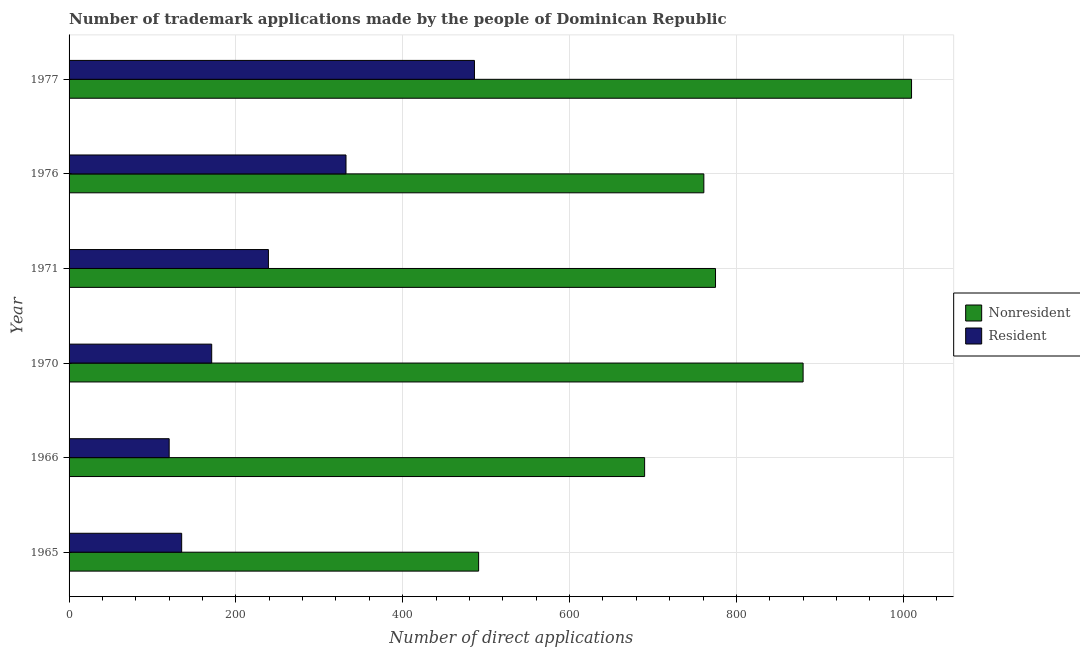How many groups of bars are there?
Provide a short and direct response. 6. Are the number of bars per tick equal to the number of legend labels?
Provide a succinct answer. Yes. Are the number of bars on each tick of the Y-axis equal?
Provide a short and direct response. Yes. What is the label of the 4th group of bars from the top?
Give a very brief answer. 1970. In how many cases, is the number of bars for a given year not equal to the number of legend labels?
Provide a short and direct response. 0. What is the number of trademark applications made by non residents in 1966?
Ensure brevity in your answer.  690. Across all years, what is the maximum number of trademark applications made by residents?
Make the answer very short. 486. Across all years, what is the minimum number of trademark applications made by non residents?
Your answer should be very brief. 491. In which year was the number of trademark applications made by residents minimum?
Provide a succinct answer. 1966. What is the total number of trademark applications made by residents in the graph?
Your answer should be very brief. 1483. What is the difference between the number of trademark applications made by non residents in 1965 and that in 1970?
Ensure brevity in your answer.  -389. What is the difference between the number of trademark applications made by non residents in 1971 and the number of trademark applications made by residents in 1965?
Your answer should be compact. 640. What is the average number of trademark applications made by residents per year?
Ensure brevity in your answer.  247.17. In the year 1970, what is the difference between the number of trademark applications made by residents and number of trademark applications made by non residents?
Your response must be concise. -709. In how many years, is the number of trademark applications made by non residents greater than 840 ?
Your response must be concise. 2. What is the ratio of the number of trademark applications made by non residents in 1970 to that in 1977?
Make the answer very short. 0.87. Is the difference between the number of trademark applications made by residents in 1966 and 1977 greater than the difference between the number of trademark applications made by non residents in 1966 and 1977?
Offer a very short reply. No. What is the difference between the highest and the second highest number of trademark applications made by non residents?
Provide a short and direct response. 130. What is the difference between the highest and the lowest number of trademark applications made by residents?
Offer a very short reply. 366. What does the 2nd bar from the top in 1977 represents?
Keep it short and to the point. Nonresident. What does the 2nd bar from the bottom in 1977 represents?
Offer a very short reply. Resident. Are all the bars in the graph horizontal?
Your response must be concise. Yes. Does the graph contain any zero values?
Make the answer very short. No. How many legend labels are there?
Provide a short and direct response. 2. How are the legend labels stacked?
Keep it short and to the point. Vertical. What is the title of the graph?
Ensure brevity in your answer.  Number of trademark applications made by the people of Dominican Republic. What is the label or title of the X-axis?
Ensure brevity in your answer.  Number of direct applications. What is the label or title of the Y-axis?
Give a very brief answer. Year. What is the Number of direct applications of Nonresident in 1965?
Provide a succinct answer. 491. What is the Number of direct applications in Resident in 1965?
Provide a succinct answer. 135. What is the Number of direct applications of Nonresident in 1966?
Your response must be concise. 690. What is the Number of direct applications in Resident in 1966?
Provide a succinct answer. 120. What is the Number of direct applications in Nonresident in 1970?
Offer a terse response. 880. What is the Number of direct applications in Resident in 1970?
Ensure brevity in your answer.  171. What is the Number of direct applications of Nonresident in 1971?
Offer a terse response. 775. What is the Number of direct applications in Resident in 1971?
Offer a very short reply. 239. What is the Number of direct applications in Nonresident in 1976?
Your answer should be compact. 761. What is the Number of direct applications of Resident in 1976?
Provide a succinct answer. 332. What is the Number of direct applications of Nonresident in 1977?
Your answer should be very brief. 1010. What is the Number of direct applications of Resident in 1977?
Provide a succinct answer. 486. Across all years, what is the maximum Number of direct applications in Nonresident?
Your answer should be compact. 1010. Across all years, what is the maximum Number of direct applications of Resident?
Your answer should be compact. 486. Across all years, what is the minimum Number of direct applications in Nonresident?
Give a very brief answer. 491. Across all years, what is the minimum Number of direct applications of Resident?
Offer a very short reply. 120. What is the total Number of direct applications in Nonresident in the graph?
Give a very brief answer. 4607. What is the total Number of direct applications of Resident in the graph?
Give a very brief answer. 1483. What is the difference between the Number of direct applications in Nonresident in 1965 and that in 1966?
Provide a short and direct response. -199. What is the difference between the Number of direct applications in Nonresident in 1965 and that in 1970?
Make the answer very short. -389. What is the difference between the Number of direct applications in Resident in 1965 and that in 1970?
Offer a very short reply. -36. What is the difference between the Number of direct applications in Nonresident in 1965 and that in 1971?
Provide a short and direct response. -284. What is the difference between the Number of direct applications of Resident in 1965 and that in 1971?
Your answer should be compact. -104. What is the difference between the Number of direct applications in Nonresident in 1965 and that in 1976?
Offer a terse response. -270. What is the difference between the Number of direct applications in Resident in 1965 and that in 1976?
Provide a short and direct response. -197. What is the difference between the Number of direct applications of Nonresident in 1965 and that in 1977?
Your response must be concise. -519. What is the difference between the Number of direct applications in Resident in 1965 and that in 1977?
Provide a succinct answer. -351. What is the difference between the Number of direct applications in Nonresident in 1966 and that in 1970?
Your answer should be compact. -190. What is the difference between the Number of direct applications of Resident in 1966 and that in 1970?
Give a very brief answer. -51. What is the difference between the Number of direct applications in Nonresident in 1966 and that in 1971?
Your response must be concise. -85. What is the difference between the Number of direct applications of Resident in 1966 and that in 1971?
Ensure brevity in your answer.  -119. What is the difference between the Number of direct applications in Nonresident in 1966 and that in 1976?
Keep it short and to the point. -71. What is the difference between the Number of direct applications of Resident in 1966 and that in 1976?
Give a very brief answer. -212. What is the difference between the Number of direct applications in Nonresident in 1966 and that in 1977?
Provide a succinct answer. -320. What is the difference between the Number of direct applications of Resident in 1966 and that in 1977?
Offer a terse response. -366. What is the difference between the Number of direct applications of Nonresident in 1970 and that in 1971?
Ensure brevity in your answer.  105. What is the difference between the Number of direct applications in Resident in 1970 and that in 1971?
Your answer should be very brief. -68. What is the difference between the Number of direct applications of Nonresident in 1970 and that in 1976?
Make the answer very short. 119. What is the difference between the Number of direct applications in Resident in 1970 and that in 1976?
Provide a succinct answer. -161. What is the difference between the Number of direct applications in Nonresident in 1970 and that in 1977?
Your answer should be compact. -130. What is the difference between the Number of direct applications of Resident in 1970 and that in 1977?
Your answer should be compact. -315. What is the difference between the Number of direct applications of Nonresident in 1971 and that in 1976?
Your response must be concise. 14. What is the difference between the Number of direct applications in Resident in 1971 and that in 1976?
Keep it short and to the point. -93. What is the difference between the Number of direct applications in Nonresident in 1971 and that in 1977?
Provide a short and direct response. -235. What is the difference between the Number of direct applications in Resident in 1971 and that in 1977?
Make the answer very short. -247. What is the difference between the Number of direct applications of Nonresident in 1976 and that in 1977?
Offer a terse response. -249. What is the difference between the Number of direct applications of Resident in 1976 and that in 1977?
Offer a terse response. -154. What is the difference between the Number of direct applications of Nonresident in 1965 and the Number of direct applications of Resident in 1966?
Provide a succinct answer. 371. What is the difference between the Number of direct applications of Nonresident in 1965 and the Number of direct applications of Resident in 1970?
Offer a very short reply. 320. What is the difference between the Number of direct applications of Nonresident in 1965 and the Number of direct applications of Resident in 1971?
Provide a short and direct response. 252. What is the difference between the Number of direct applications in Nonresident in 1965 and the Number of direct applications in Resident in 1976?
Keep it short and to the point. 159. What is the difference between the Number of direct applications of Nonresident in 1966 and the Number of direct applications of Resident in 1970?
Your answer should be very brief. 519. What is the difference between the Number of direct applications in Nonresident in 1966 and the Number of direct applications in Resident in 1971?
Offer a terse response. 451. What is the difference between the Number of direct applications in Nonresident in 1966 and the Number of direct applications in Resident in 1976?
Provide a short and direct response. 358. What is the difference between the Number of direct applications of Nonresident in 1966 and the Number of direct applications of Resident in 1977?
Ensure brevity in your answer.  204. What is the difference between the Number of direct applications in Nonresident in 1970 and the Number of direct applications in Resident in 1971?
Ensure brevity in your answer.  641. What is the difference between the Number of direct applications of Nonresident in 1970 and the Number of direct applications of Resident in 1976?
Your response must be concise. 548. What is the difference between the Number of direct applications of Nonresident in 1970 and the Number of direct applications of Resident in 1977?
Your response must be concise. 394. What is the difference between the Number of direct applications of Nonresident in 1971 and the Number of direct applications of Resident in 1976?
Your answer should be compact. 443. What is the difference between the Number of direct applications in Nonresident in 1971 and the Number of direct applications in Resident in 1977?
Offer a very short reply. 289. What is the difference between the Number of direct applications of Nonresident in 1976 and the Number of direct applications of Resident in 1977?
Offer a very short reply. 275. What is the average Number of direct applications in Nonresident per year?
Make the answer very short. 767.83. What is the average Number of direct applications of Resident per year?
Your response must be concise. 247.17. In the year 1965, what is the difference between the Number of direct applications in Nonresident and Number of direct applications in Resident?
Offer a very short reply. 356. In the year 1966, what is the difference between the Number of direct applications in Nonresident and Number of direct applications in Resident?
Offer a very short reply. 570. In the year 1970, what is the difference between the Number of direct applications in Nonresident and Number of direct applications in Resident?
Your response must be concise. 709. In the year 1971, what is the difference between the Number of direct applications of Nonresident and Number of direct applications of Resident?
Provide a short and direct response. 536. In the year 1976, what is the difference between the Number of direct applications in Nonresident and Number of direct applications in Resident?
Your answer should be compact. 429. In the year 1977, what is the difference between the Number of direct applications of Nonresident and Number of direct applications of Resident?
Provide a short and direct response. 524. What is the ratio of the Number of direct applications in Nonresident in 1965 to that in 1966?
Keep it short and to the point. 0.71. What is the ratio of the Number of direct applications of Resident in 1965 to that in 1966?
Your answer should be compact. 1.12. What is the ratio of the Number of direct applications of Nonresident in 1965 to that in 1970?
Your answer should be compact. 0.56. What is the ratio of the Number of direct applications in Resident in 1965 to that in 1970?
Offer a very short reply. 0.79. What is the ratio of the Number of direct applications of Nonresident in 1965 to that in 1971?
Offer a very short reply. 0.63. What is the ratio of the Number of direct applications of Resident in 1965 to that in 1971?
Provide a short and direct response. 0.56. What is the ratio of the Number of direct applications in Nonresident in 1965 to that in 1976?
Keep it short and to the point. 0.65. What is the ratio of the Number of direct applications in Resident in 1965 to that in 1976?
Ensure brevity in your answer.  0.41. What is the ratio of the Number of direct applications of Nonresident in 1965 to that in 1977?
Give a very brief answer. 0.49. What is the ratio of the Number of direct applications of Resident in 1965 to that in 1977?
Your answer should be very brief. 0.28. What is the ratio of the Number of direct applications of Nonresident in 1966 to that in 1970?
Your response must be concise. 0.78. What is the ratio of the Number of direct applications of Resident in 1966 to that in 1970?
Offer a very short reply. 0.7. What is the ratio of the Number of direct applications in Nonresident in 1966 to that in 1971?
Your answer should be compact. 0.89. What is the ratio of the Number of direct applications in Resident in 1966 to that in 1971?
Give a very brief answer. 0.5. What is the ratio of the Number of direct applications of Nonresident in 1966 to that in 1976?
Offer a very short reply. 0.91. What is the ratio of the Number of direct applications in Resident in 1966 to that in 1976?
Ensure brevity in your answer.  0.36. What is the ratio of the Number of direct applications in Nonresident in 1966 to that in 1977?
Keep it short and to the point. 0.68. What is the ratio of the Number of direct applications in Resident in 1966 to that in 1977?
Offer a terse response. 0.25. What is the ratio of the Number of direct applications of Nonresident in 1970 to that in 1971?
Offer a very short reply. 1.14. What is the ratio of the Number of direct applications in Resident in 1970 to that in 1971?
Your answer should be compact. 0.72. What is the ratio of the Number of direct applications in Nonresident in 1970 to that in 1976?
Keep it short and to the point. 1.16. What is the ratio of the Number of direct applications in Resident in 1970 to that in 1976?
Your response must be concise. 0.52. What is the ratio of the Number of direct applications in Nonresident in 1970 to that in 1977?
Your answer should be very brief. 0.87. What is the ratio of the Number of direct applications of Resident in 1970 to that in 1977?
Make the answer very short. 0.35. What is the ratio of the Number of direct applications in Nonresident in 1971 to that in 1976?
Your answer should be compact. 1.02. What is the ratio of the Number of direct applications of Resident in 1971 to that in 1976?
Keep it short and to the point. 0.72. What is the ratio of the Number of direct applications in Nonresident in 1971 to that in 1977?
Keep it short and to the point. 0.77. What is the ratio of the Number of direct applications in Resident in 1971 to that in 1977?
Give a very brief answer. 0.49. What is the ratio of the Number of direct applications in Nonresident in 1976 to that in 1977?
Make the answer very short. 0.75. What is the ratio of the Number of direct applications of Resident in 1976 to that in 1977?
Your response must be concise. 0.68. What is the difference between the highest and the second highest Number of direct applications of Nonresident?
Your answer should be very brief. 130. What is the difference between the highest and the second highest Number of direct applications in Resident?
Make the answer very short. 154. What is the difference between the highest and the lowest Number of direct applications in Nonresident?
Make the answer very short. 519. What is the difference between the highest and the lowest Number of direct applications in Resident?
Your answer should be very brief. 366. 